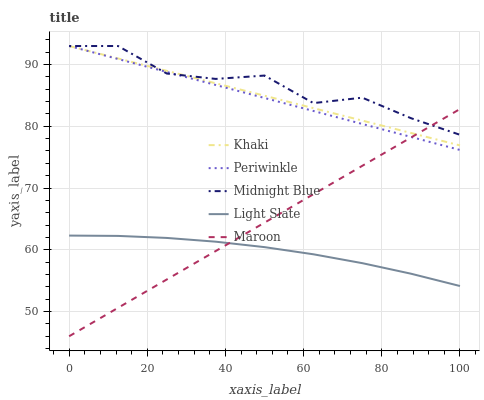Does Light Slate have the minimum area under the curve?
Answer yes or no. Yes. Does Midnight Blue have the maximum area under the curve?
Answer yes or no. Yes. Does Khaki have the minimum area under the curve?
Answer yes or no. No. Does Khaki have the maximum area under the curve?
Answer yes or no. No. Is Khaki the smoothest?
Answer yes or no. Yes. Is Midnight Blue the roughest?
Answer yes or no. Yes. Is Periwinkle the smoothest?
Answer yes or no. No. Is Periwinkle the roughest?
Answer yes or no. No. Does Maroon have the lowest value?
Answer yes or no. Yes. Does Khaki have the lowest value?
Answer yes or no. No. Does Midnight Blue have the highest value?
Answer yes or no. Yes. Does Maroon have the highest value?
Answer yes or no. No. Is Light Slate less than Periwinkle?
Answer yes or no. Yes. Is Khaki greater than Light Slate?
Answer yes or no. Yes. Does Midnight Blue intersect Maroon?
Answer yes or no. Yes. Is Midnight Blue less than Maroon?
Answer yes or no. No. Is Midnight Blue greater than Maroon?
Answer yes or no. No. Does Light Slate intersect Periwinkle?
Answer yes or no. No. 